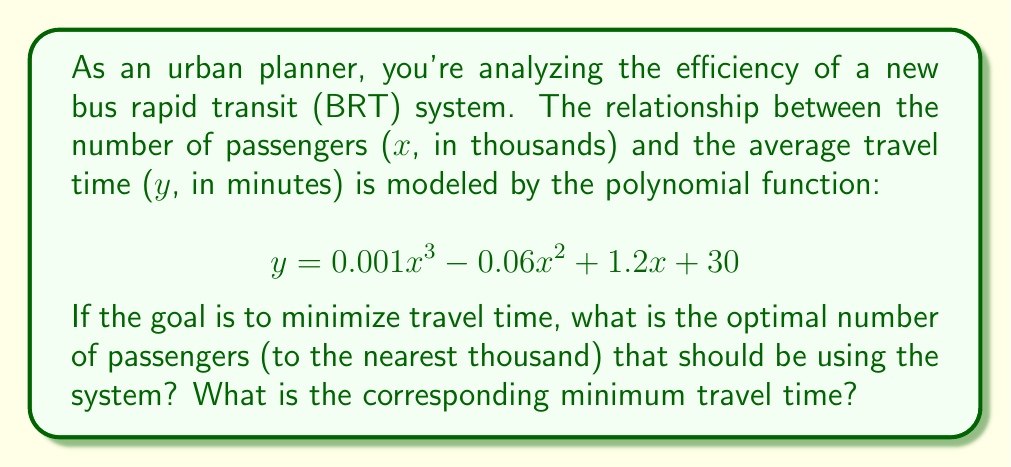What is the answer to this math problem? To find the optimal number of passengers that minimizes travel time, we need to find the minimum point of the given polynomial function. This can be done by following these steps:

1. Find the derivative of the function:
   $$ \frac{dy}{dx} = 0.003x^2 - 0.12x + 1.2 $$

2. Set the derivative equal to zero and solve for x:
   $$ 0.003x^2 - 0.12x + 1.2 = 0 $$

3. This is a quadratic equation. We can solve it using the quadratic formula:
   $$ x = \frac{-b \pm \sqrt{b^2 - 4ac}}{2a} $$
   where $a = 0.003$, $b = -0.12$, and $c = 1.2$

4. Plugging in the values:
   $$ x = \frac{0.12 \pm \sqrt{(-0.12)^2 - 4(0.003)(1.2)}}{2(0.003)} $$
   $$ x = \frac{0.12 \pm \sqrt{0.0144 - 0.0144}}{0.006} $$
   $$ x = \frac{0.12 \pm 0}{0.006} = 20 $$

5. The second derivative is $0.006x - 0.12$, which is positive when $x > 20$. This confirms that $x = 20$ is a minimum point.

6. To find the minimum travel time, plug $x = 20$ into the original function:
   $$ y = 0.001(20)^3 - 0.06(20)^2 + 1.2(20) + 30 $$
   $$ y = 8 - 24 + 24 + 30 = 38 $$

Therefore, the optimal number of passengers is 20,000 (to the nearest thousand), and the corresponding minimum travel time is 38 minutes.
Answer: The optimal number of passengers is 20,000, and the minimum travel time is 38 minutes. 